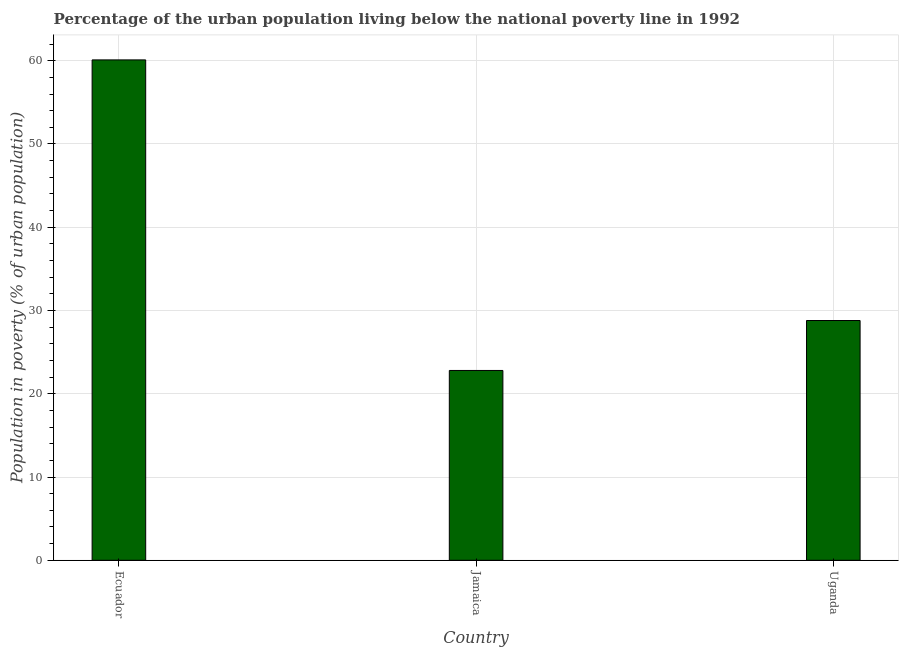What is the title of the graph?
Ensure brevity in your answer.  Percentage of the urban population living below the national poverty line in 1992. What is the label or title of the X-axis?
Keep it short and to the point. Country. What is the label or title of the Y-axis?
Keep it short and to the point. Population in poverty (% of urban population). What is the percentage of urban population living below poverty line in Jamaica?
Make the answer very short. 22.8. Across all countries, what is the maximum percentage of urban population living below poverty line?
Provide a succinct answer. 60.1. Across all countries, what is the minimum percentage of urban population living below poverty line?
Your answer should be compact. 22.8. In which country was the percentage of urban population living below poverty line maximum?
Ensure brevity in your answer.  Ecuador. In which country was the percentage of urban population living below poverty line minimum?
Your answer should be compact. Jamaica. What is the sum of the percentage of urban population living below poverty line?
Provide a succinct answer. 111.7. What is the difference between the percentage of urban population living below poverty line in Ecuador and Uganda?
Your answer should be compact. 31.3. What is the average percentage of urban population living below poverty line per country?
Your answer should be compact. 37.23. What is the median percentage of urban population living below poverty line?
Your answer should be very brief. 28.8. In how many countries, is the percentage of urban population living below poverty line greater than 60 %?
Provide a succinct answer. 1. What is the ratio of the percentage of urban population living below poverty line in Ecuador to that in Jamaica?
Your answer should be compact. 2.64. Is the percentage of urban population living below poverty line in Jamaica less than that in Uganda?
Your answer should be very brief. Yes. Is the difference between the percentage of urban population living below poverty line in Ecuador and Uganda greater than the difference between any two countries?
Provide a succinct answer. No. What is the difference between the highest and the second highest percentage of urban population living below poverty line?
Ensure brevity in your answer.  31.3. What is the difference between the highest and the lowest percentage of urban population living below poverty line?
Ensure brevity in your answer.  37.3. In how many countries, is the percentage of urban population living below poverty line greater than the average percentage of urban population living below poverty line taken over all countries?
Offer a very short reply. 1. How many bars are there?
Offer a terse response. 3. Are the values on the major ticks of Y-axis written in scientific E-notation?
Provide a succinct answer. No. What is the Population in poverty (% of urban population) of Ecuador?
Your answer should be compact. 60.1. What is the Population in poverty (% of urban population) in Jamaica?
Provide a succinct answer. 22.8. What is the Population in poverty (% of urban population) in Uganda?
Your answer should be compact. 28.8. What is the difference between the Population in poverty (% of urban population) in Ecuador and Jamaica?
Provide a short and direct response. 37.3. What is the difference between the Population in poverty (% of urban population) in Ecuador and Uganda?
Your answer should be compact. 31.3. What is the difference between the Population in poverty (% of urban population) in Jamaica and Uganda?
Provide a succinct answer. -6. What is the ratio of the Population in poverty (% of urban population) in Ecuador to that in Jamaica?
Keep it short and to the point. 2.64. What is the ratio of the Population in poverty (% of urban population) in Ecuador to that in Uganda?
Your response must be concise. 2.09. What is the ratio of the Population in poverty (% of urban population) in Jamaica to that in Uganda?
Offer a terse response. 0.79. 